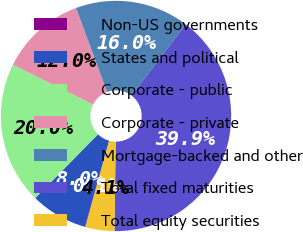Convert chart to OTSL. <chart><loc_0><loc_0><loc_500><loc_500><pie_chart><fcel>Non-US governments<fcel>States and political<fcel>Corporate - public<fcel>Corporate - private<fcel>Mortgage-backed and other<fcel>Total fixed maturities<fcel>Total equity securities<nl><fcel>0.07%<fcel>8.03%<fcel>19.97%<fcel>12.01%<fcel>15.99%<fcel>39.87%<fcel>4.05%<nl></chart> 